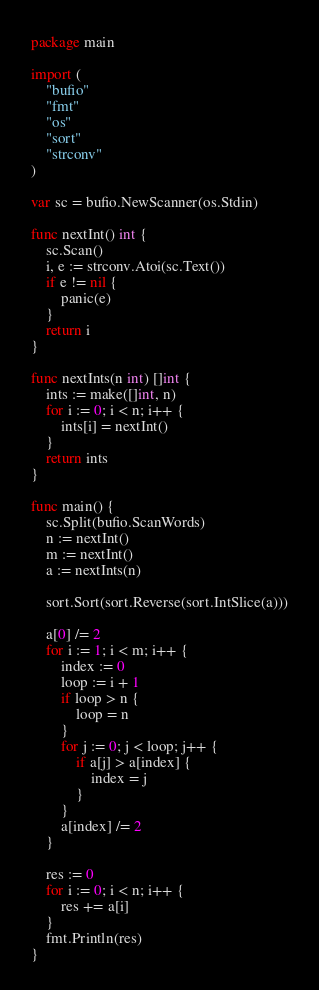<code> <loc_0><loc_0><loc_500><loc_500><_Go_>package main

import (
	"bufio"
	"fmt"
	"os"
	"sort"
	"strconv"
)

var sc = bufio.NewScanner(os.Stdin)

func nextInt() int {
	sc.Scan()
	i, e := strconv.Atoi(sc.Text())
	if e != nil {
		panic(e)
	}
	return i
}

func nextInts(n int) []int {
	ints := make([]int, n)
	for i := 0; i < n; i++ {
		ints[i] = nextInt()
	}
	return ints
}

func main() {
	sc.Split(bufio.ScanWords)
	n := nextInt()
	m := nextInt()
	a := nextInts(n)

	sort.Sort(sort.Reverse(sort.IntSlice(a)))

	a[0] /= 2
	for i := 1; i < m; i++ {
		index := 0
		loop := i + 1
		if loop > n {
			loop = n
		}
		for j := 0; j < loop; j++ {
			if a[j] > a[index] {
				index = j
			}
		}
		a[index] /= 2
	}

	res := 0
	for i := 0; i < n; i++ {
		res += a[i]
	}
	fmt.Println(res)
}
</code> 